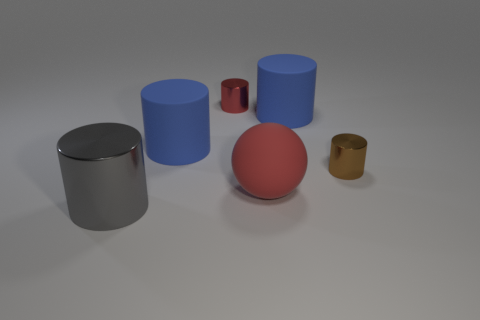Is the red sphere made of the same material as the gray thing?
Provide a short and direct response. No. What number of metallic cylinders are left of the big blue matte object on the right side of the large matte sphere?
Provide a succinct answer. 2. Does the gray object have the same size as the brown metallic thing?
Your response must be concise. No. How many other spheres are made of the same material as the sphere?
Make the answer very short. 0. The other brown thing that is the same shape as the big shiny object is what size?
Your answer should be very brief. Small. Do the red thing that is behind the red sphere and the big shiny thing have the same shape?
Provide a short and direct response. Yes. What is the shape of the big thing to the left of the blue rubber cylinder that is on the left side of the small red cylinder?
Give a very brief answer. Cylinder. Are there any other things that are the same shape as the large red rubber thing?
Provide a succinct answer. No. There is a large shiny thing that is the same shape as the tiny red shiny thing; what color is it?
Give a very brief answer. Gray. There is a big matte ball; is it the same color as the small object that is on the left side of the big ball?
Your answer should be compact. Yes. 